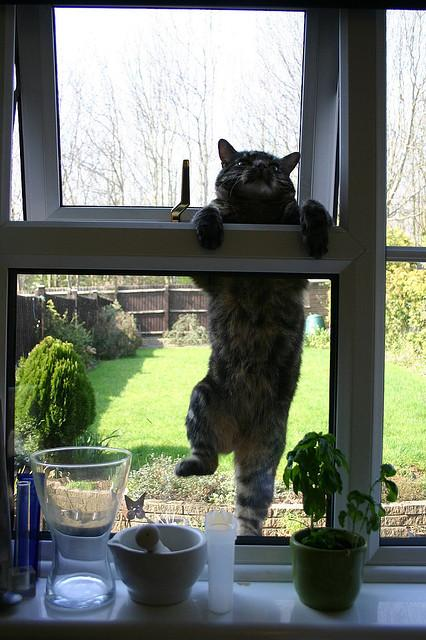What is the cat climbing through?

Choices:
A) cupboard
B) window
C) chimney
D) door window 